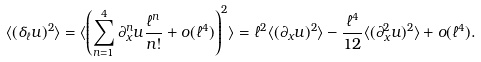Convert formula to latex. <formula><loc_0><loc_0><loc_500><loc_500>\langle ( \delta _ { \ell } u ) ^ { 2 } \rangle = \langle \left ( \sum _ { n = 1 } ^ { 4 } \partial ^ { n } _ { x } u \frac { \ell ^ { n } } { n ! } + o ( \ell ^ { 4 } ) \right ) ^ { 2 } \rangle = \ell ^ { 2 } \langle ( \partial _ { x } u ) ^ { 2 } \rangle - \frac { \ell ^ { 4 } } { 1 2 } \langle ( \partial ^ { 2 } _ { x } u ) ^ { 2 } \rangle + o ( \ell ^ { 4 } ) .</formula> 